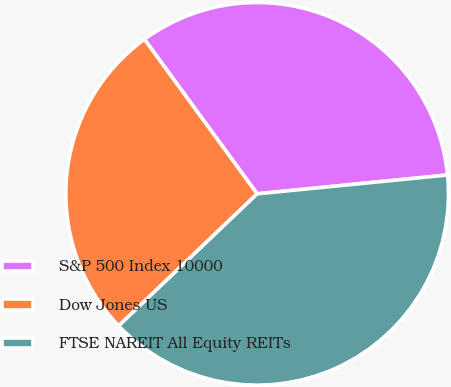Convert chart to OTSL. <chart><loc_0><loc_0><loc_500><loc_500><pie_chart><fcel>S&P 500 Index 10000<fcel>Dow Jones US<fcel>FTSE NAREIT All Equity REITs<nl><fcel>33.46%<fcel>27.09%<fcel>39.45%<nl></chart> 